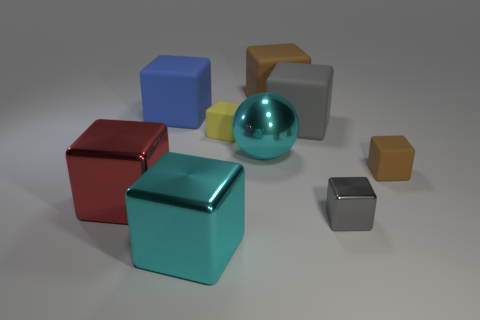Subtract 5 blocks. How many blocks are left? 3 Subtract all gray cubes. How many cubes are left? 6 Subtract all blue matte blocks. How many blocks are left? 7 Subtract all red blocks. Subtract all green balls. How many blocks are left? 7 Subtract all spheres. How many objects are left? 8 Subtract 0 cyan cylinders. How many objects are left? 9 Subtract all yellow blocks. Subtract all big matte objects. How many objects are left? 5 Add 7 gray metallic cubes. How many gray metallic cubes are left? 8 Add 7 metallic balls. How many metallic balls exist? 8 